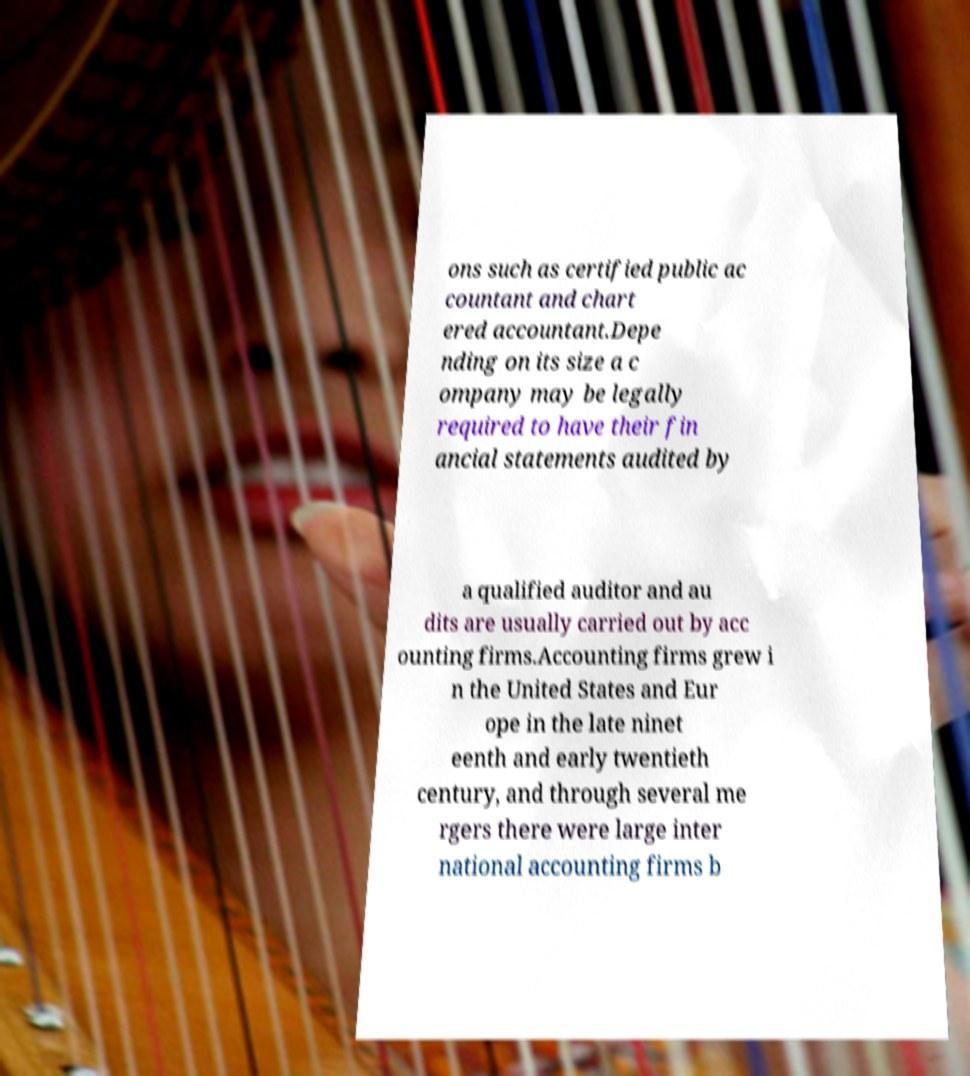Could you extract and type out the text from this image? ons such as certified public ac countant and chart ered accountant.Depe nding on its size a c ompany may be legally required to have their fin ancial statements audited by a qualified auditor and au dits are usually carried out by acc ounting firms.Accounting firms grew i n the United States and Eur ope in the late ninet eenth and early twentieth century, and through several me rgers there were large inter national accounting firms b 